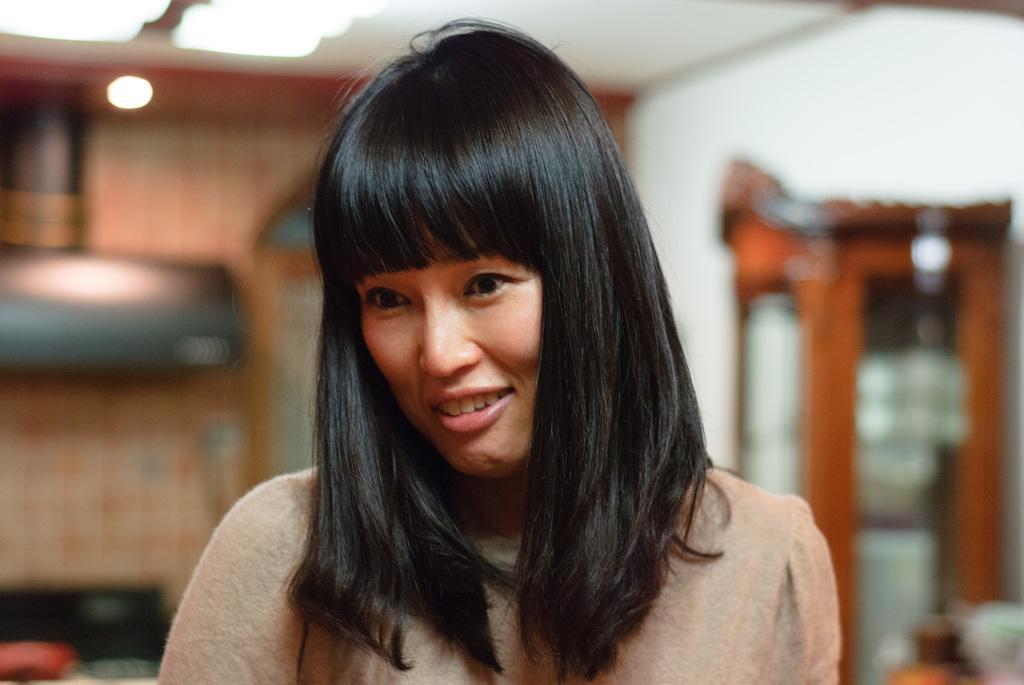Please provide a concise description of this image. In this image I can see a woman. In the background, I can see the wall and a door. At the top I can see the lights. 